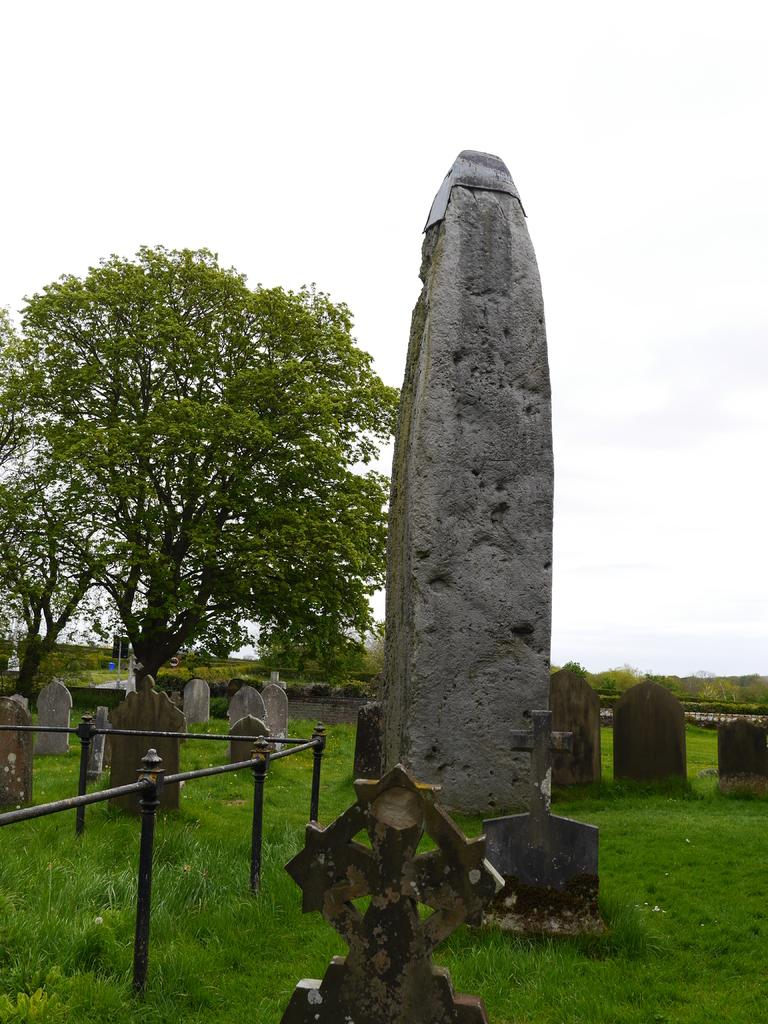What can be seen in the image that represents burial sites? There are graves in the image. What type of vegetation is present on the ground in the image? There is green grass on the ground. What type of structure is present in the image? There is a pillar in the image. What are the small poles in the image used for? The small poles in the image are likely used for marking or decoration. What is visible at the top of the image? The sky is visible at the top of the image. What type of vest is worn by the condition in the image? There is no vest or condition present in the image; it features graves, green grass, a pillar, small poles, and the sky. 